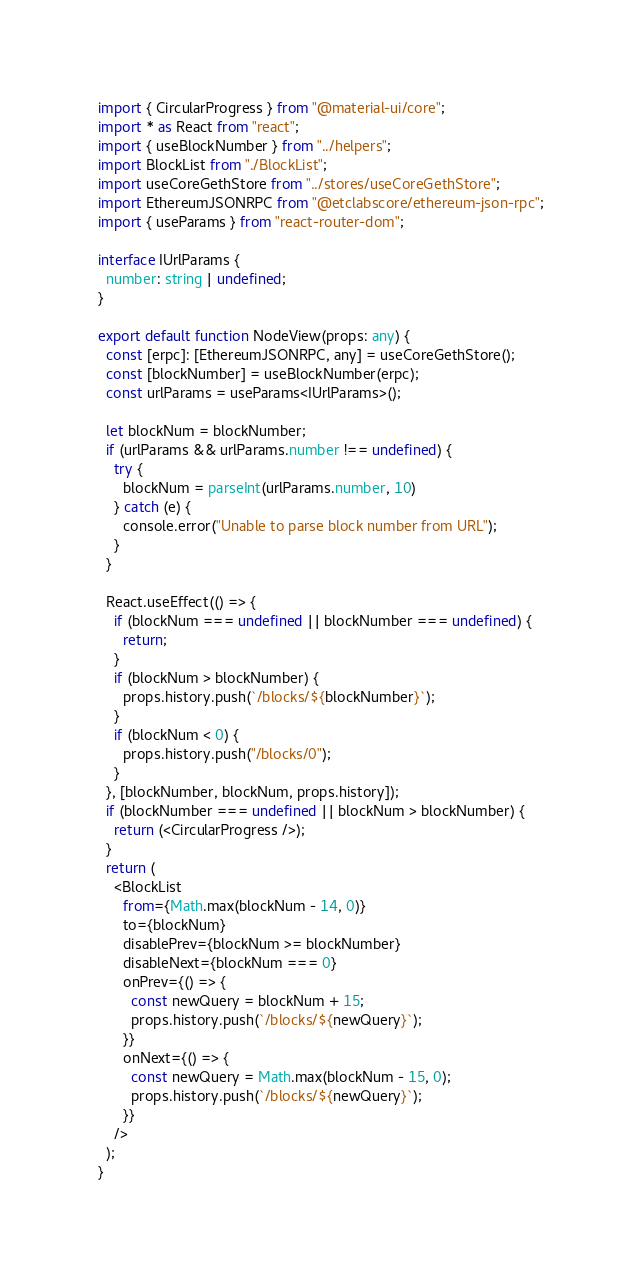Convert code to text. <code><loc_0><loc_0><loc_500><loc_500><_TypeScript_>import { CircularProgress } from "@material-ui/core";
import * as React from "react";
import { useBlockNumber } from "../helpers";
import BlockList from "./BlockList";
import useCoreGethStore from "../stores/useCoreGethStore";
import EthereumJSONRPC from "@etclabscore/ethereum-json-rpc";
import { useParams } from "react-router-dom";

interface IUrlParams {
  number: string | undefined;
}

export default function NodeView(props: any) {
  const [erpc]: [EthereumJSONRPC, any] = useCoreGethStore();
  const [blockNumber] = useBlockNumber(erpc);
  const urlParams = useParams<IUrlParams>();

  let blockNum = blockNumber;
  if (urlParams && urlParams.number !== undefined) {
    try {
      blockNum = parseInt(urlParams.number, 10)
    } catch (e) {
      console.error("Unable to parse block number from URL");
    }
  }

  React.useEffect(() => {
    if (blockNum === undefined || blockNumber === undefined) {
      return;
    }
    if (blockNum > blockNumber) {
      props.history.push(`/blocks/${blockNumber}`);
    }
    if (blockNum < 0) {
      props.history.push("/blocks/0");
    }
  }, [blockNumber, blockNum, props.history]);
  if (blockNumber === undefined || blockNum > blockNumber) {
    return (<CircularProgress />);
  }
  return (
    <BlockList
      from={Math.max(blockNum - 14, 0)}
      to={blockNum}
      disablePrev={blockNum >= blockNumber}
      disableNext={blockNum === 0}
      onPrev={() => {
        const newQuery = blockNum + 15;
        props.history.push(`/blocks/${newQuery}`);
      }}
      onNext={() => {
        const newQuery = Math.max(blockNum - 15, 0);
        props.history.push(`/blocks/${newQuery}`);
      }}
    />
  );
}
</code> 